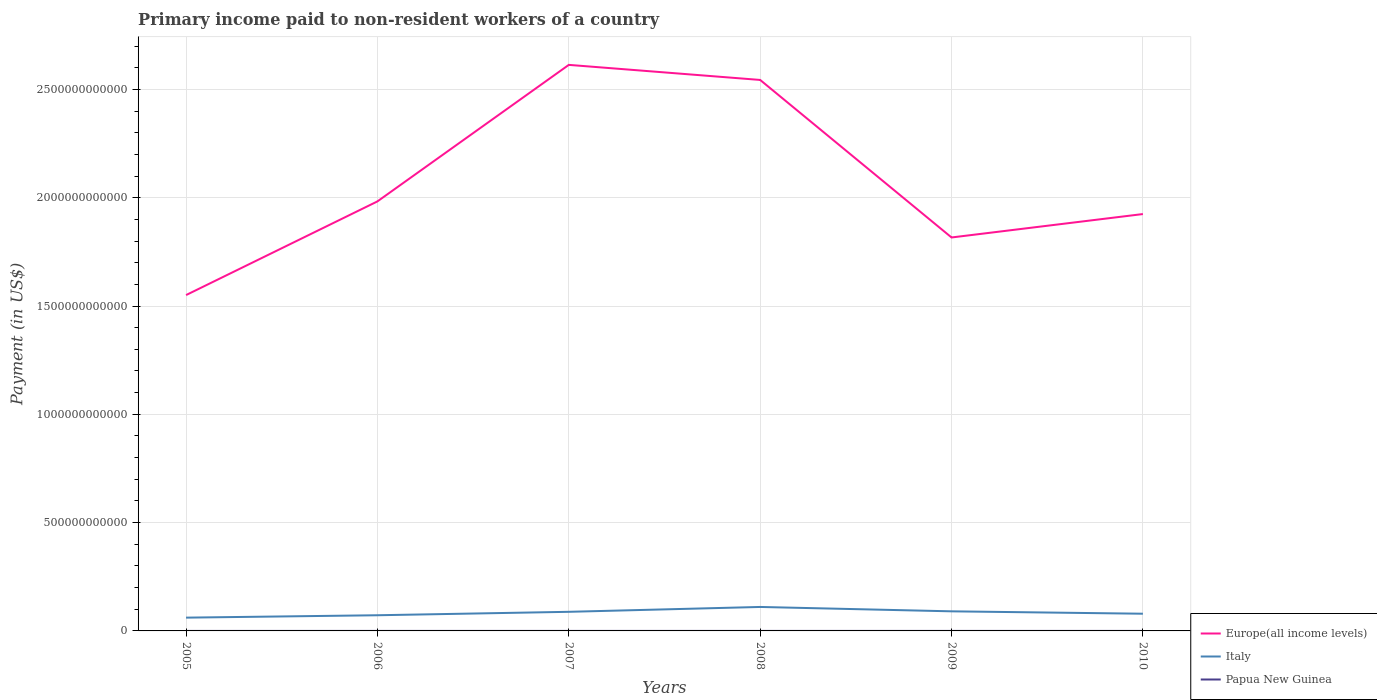How many different coloured lines are there?
Provide a succinct answer. 3. Across all years, what is the maximum amount paid to workers in Italy?
Keep it short and to the point. 6.13e+1. In which year was the amount paid to workers in Europe(all income levels) maximum?
Your response must be concise. 2005. What is the total amount paid to workers in Papua New Guinea in the graph?
Your answer should be compact. -7.82e+07. What is the difference between the highest and the second highest amount paid to workers in Papua New Guinea?
Your answer should be compact. 7.82e+07. What is the difference between two consecutive major ticks on the Y-axis?
Keep it short and to the point. 5.00e+11. Does the graph contain any zero values?
Provide a short and direct response. No. Does the graph contain grids?
Keep it short and to the point. Yes. Where does the legend appear in the graph?
Your answer should be very brief. Bottom right. How many legend labels are there?
Ensure brevity in your answer.  3. How are the legend labels stacked?
Keep it short and to the point. Vertical. What is the title of the graph?
Ensure brevity in your answer.  Primary income paid to non-resident workers of a country. Does "Cabo Verde" appear as one of the legend labels in the graph?
Offer a terse response. No. What is the label or title of the Y-axis?
Your answer should be compact. Payment (in US$). What is the Payment (in US$) in Europe(all income levels) in 2005?
Make the answer very short. 1.55e+12. What is the Payment (in US$) in Italy in 2005?
Your answer should be very brief. 6.13e+1. What is the Payment (in US$) of Papua New Guinea in 2005?
Your response must be concise. 2.61e+07. What is the Payment (in US$) of Europe(all income levels) in 2006?
Make the answer very short. 1.98e+12. What is the Payment (in US$) in Italy in 2006?
Make the answer very short. 7.24e+1. What is the Payment (in US$) in Papua New Guinea in 2006?
Offer a terse response. 7.03e+07. What is the Payment (in US$) of Europe(all income levels) in 2007?
Your answer should be very brief. 2.61e+12. What is the Payment (in US$) in Italy in 2007?
Provide a succinct answer. 8.82e+1. What is the Payment (in US$) in Papua New Guinea in 2007?
Your answer should be compact. 1.04e+08. What is the Payment (in US$) in Europe(all income levels) in 2008?
Provide a short and direct response. 2.54e+12. What is the Payment (in US$) in Italy in 2008?
Offer a very short reply. 1.11e+11. What is the Payment (in US$) in Papua New Guinea in 2008?
Make the answer very short. 8.51e+07. What is the Payment (in US$) in Europe(all income levels) in 2009?
Offer a very short reply. 1.82e+12. What is the Payment (in US$) of Italy in 2009?
Your answer should be very brief. 9.04e+1. What is the Payment (in US$) of Papua New Guinea in 2009?
Offer a terse response. 4.63e+07. What is the Payment (in US$) of Europe(all income levels) in 2010?
Offer a very short reply. 1.92e+12. What is the Payment (in US$) of Italy in 2010?
Offer a very short reply. 7.94e+1. What is the Payment (in US$) in Papua New Guinea in 2010?
Ensure brevity in your answer.  4.16e+07. Across all years, what is the maximum Payment (in US$) of Europe(all income levels)?
Provide a succinct answer. 2.61e+12. Across all years, what is the maximum Payment (in US$) in Italy?
Your response must be concise. 1.11e+11. Across all years, what is the maximum Payment (in US$) in Papua New Guinea?
Your answer should be compact. 1.04e+08. Across all years, what is the minimum Payment (in US$) of Europe(all income levels)?
Offer a very short reply. 1.55e+12. Across all years, what is the minimum Payment (in US$) in Italy?
Offer a very short reply. 6.13e+1. Across all years, what is the minimum Payment (in US$) of Papua New Guinea?
Offer a terse response. 2.61e+07. What is the total Payment (in US$) of Europe(all income levels) in the graph?
Your answer should be very brief. 1.24e+13. What is the total Payment (in US$) in Italy in the graph?
Ensure brevity in your answer.  5.02e+11. What is the total Payment (in US$) in Papua New Guinea in the graph?
Offer a very short reply. 3.74e+08. What is the difference between the Payment (in US$) of Europe(all income levels) in 2005 and that in 2006?
Provide a short and direct response. -4.33e+11. What is the difference between the Payment (in US$) of Italy in 2005 and that in 2006?
Provide a succinct answer. -1.10e+1. What is the difference between the Payment (in US$) of Papua New Guinea in 2005 and that in 2006?
Give a very brief answer. -4.42e+07. What is the difference between the Payment (in US$) in Europe(all income levels) in 2005 and that in 2007?
Offer a terse response. -1.06e+12. What is the difference between the Payment (in US$) in Italy in 2005 and that in 2007?
Make the answer very short. -2.69e+1. What is the difference between the Payment (in US$) in Papua New Guinea in 2005 and that in 2007?
Offer a very short reply. -7.82e+07. What is the difference between the Payment (in US$) of Europe(all income levels) in 2005 and that in 2008?
Offer a terse response. -9.93e+11. What is the difference between the Payment (in US$) in Italy in 2005 and that in 2008?
Give a very brief answer. -4.93e+1. What is the difference between the Payment (in US$) of Papua New Guinea in 2005 and that in 2008?
Ensure brevity in your answer.  -5.90e+07. What is the difference between the Payment (in US$) in Europe(all income levels) in 2005 and that in 2009?
Provide a succinct answer. -2.66e+11. What is the difference between the Payment (in US$) of Italy in 2005 and that in 2009?
Ensure brevity in your answer.  -2.91e+1. What is the difference between the Payment (in US$) in Papua New Guinea in 2005 and that in 2009?
Keep it short and to the point. -2.02e+07. What is the difference between the Payment (in US$) of Europe(all income levels) in 2005 and that in 2010?
Provide a short and direct response. -3.74e+11. What is the difference between the Payment (in US$) of Italy in 2005 and that in 2010?
Your answer should be compact. -1.81e+1. What is the difference between the Payment (in US$) of Papua New Guinea in 2005 and that in 2010?
Provide a succinct answer. -1.54e+07. What is the difference between the Payment (in US$) of Europe(all income levels) in 2006 and that in 2007?
Provide a short and direct response. -6.30e+11. What is the difference between the Payment (in US$) in Italy in 2006 and that in 2007?
Make the answer very short. -1.59e+1. What is the difference between the Payment (in US$) in Papua New Guinea in 2006 and that in 2007?
Make the answer very short. -3.40e+07. What is the difference between the Payment (in US$) in Europe(all income levels) in 2006 and that in 2008?
Offer a terse response. -5.61e+11. What is the difference between the Payment (in US$) of Italy in 2006 and that in 2008?
Your answer should be very brief. -3.83e+1. What is the difference between the Payment (in US$) of Papua New Guinea in 2006 and that in 2008?
Offer a terse response. -1.48e+07. What is the difference between the Payment (in US$) in Europe(all income levels) in 2006 and that in 2009?
Your answer should be compact. 1.67e+11. What is the difference between the Payment (in US$) in Italy in 2006 and that in 2009?
Provide a short and direct response. -1.81e+1. What is the difference between the Payment (in US$) of Papua New Guinea in 2006 and that in 2009?
Your answer should be very brief. 2.40e+07. What is the difference between the Payment (in US$) of Europe(all income levels) in 2006 and that in 2010?
Your response must be concise. 5.85e+1. What is the difference between the Payment (in US$) in Italy in 2006 and that in 2010?
Provide a short and direct response. -7.08e+09. What is the difference between the Payment (in US$) of Papua New Guinea in 2006 and that in 2010?
Provide a short and direct response. 2.87e+07. What is the difference between the Payment (in US$) in Europe(all income levels) in 2007 and that in 2008?
Ensure brevity in your answer.  6.96e+1. What is the difference between the Payment (in US$) in Italy in 2007 and that in 2008?
Your answer should be compact. -2.24e+1. What is the difference between the Payment (in US$) in Papua New Guinea in 2007 and that in 2008?
Provide a succinct answer. 1.92e+07. What is the difference between the Payment (in US$) of Europe(all income levels) in 2007 and that in 2009?
Ensure brevity in your answer.  7.97e+11. What is the difference between the Payment (in US$) in Italy in 2007 and that in 2009?
Your response must be concise. -2.21e+09. What is the difference between the Payment (in US$) of Papua New Guinea in 2007 and that in 2009?
Your answer should be very brief. 5.80e+07. What is the difference between the Payment (in US$) of Europe(all income levels) in 2007 and that in 2010?
Offer a terse response. 6.89e+11. What is the difference between the Payment (in US$) of Italy in 2007 and that in 2010?
Offer a very short reply. 8.79e+09. What is the difference between the Payment (in US$) in Papua New Guinea in 2007 and that in 2010?
Offer a very short reply. 6.28e+07. What is the difference between the Payment (in US$) in Europe(all income levels) in 2008 and that in 2009?
Ensure brevity in your answer.  7.27e+11. What is the difference between the Payment (in US$) in Italy in 2008 and that in 2009?
Your answer should be very brief. 2.02e+1. What is the difference between the Payment (in US$) in Papua New Guinea in 2008 and that in 2009?
Provide a short and direct response. 3.88e+07. What is the difference between the Payment (in US$) in Europe(all income levels) in 2008 and that in 2010?
Provide a short and direct response. 6.19e+11. What is the difference between the Payment (in US$) in Italy in 2008 and that in 2010?
Your answer should be compact. 3.12e+1. What is the difference between the Payment (in US$) of Papua New Guinea in 2008 and that in 2010?
Ensure brevity in your answer.  4.36e+07. What is the difference between the Payment (in US$) in Europe(all income levels) in 2009 and that in 2010?
Make the answer very short. -1.08e+11. What is the difference between the Payment (in US$) in Italy in 2009 and that in 2010?
Offer a very short reply. 1.10e+1. What is the difference between the Payment (in US$) in Papua New Guinea in 2009 and that in 2010?
Offer a terse response. 4.76e+06. What is the difference between the Payment (in US$) of Europe(all income levels) in 2005 and the Payment (in US$) of Italy in 2006?
Keep it short and to the point. 1.48e+12. What is the difference between the Payment (in US$) in Europe(all income levels) in 2005 and the Payment (in US$) in Papua New Guinea in 2006?
Offer a very short reply. 1.55e+12. What is the difference between the Payment (in US$) of Italy in 2005 and the Payment (in US$) of Papua New Guinea in 2006?
Ensure brevity in your answer.  6.13e+1. What is the difference between the Payment (in US$) of Europe(all income levels) in 2005 and the Payment (in US$) of Italy in 2007?
Give a very brief answer. 1.46e+12. What is the difference between the Payment (in US$) in Europe(all income levels) in 2005 and the Payment (in US$) in Papua New Guinea in 2007?
Keep it short and to the point. 1.55e+12. What is the difference between the Payment (in US$) in Italy in 2005 and the Payment (in US$) in Papua New Guinea in 2007?
Keep it short and to the point. 6.12e+1. What is the difference between the Payment (in US$) in Europe(all income levels) in 2005 and the Payment (in US$) in Italy in 2008?
Ensure brevity in your answer.  1.44e+12. What is the difference between the Payment (in US$) of Europe(all income levels) in 2005 and the Payment (in US$) of Papua New Guinea in 2008?
Provide a succinct answer. 1.55e+12. What is the difference between the Payment (in US$) in Italy in 2005 and the Payment (in US$) in Papua New Guinea in 2008?
Ensure brevity in your answer.  6.12e+1. What is the difference between the Payment (in US$) in Europe(all income levels) in 2005 and the Payment (in US$) in Italy in 2009?
Give a very brief answer. 1.46e+12. What is the difference between the Payment (in US$) in Europe(all income levels) in 2005 and the Payment (in US$) in Papua New Guinea in 2009?
Provide a short and direct response. 1.55e+12. What is the difference between the Payment (in US$) in Italy in 2005 and the Payment (in US$) in Papua New Guinea in 2009?
Ensure brevity in your answer.  6.13e+1. What is the difference between the Payment (in US$) in Europe(all income levels) in 2005 and the Payment (in US$) in Italy in 2010?
Your answer should be very brief. 1.47e+12. What is the difference between the Payment (in US$) of Europe(all income levels) in 2005 and the Payment (in US$) of Papua New Guinea in 2010?
Your answer should be very brief. 1.55e+12. What is the difference between the Payment (in US$) in Italy in 2005 and the Payment (in US$) in Papua New Guinea in 2010?
Ensure brevity in your answer.  6.13e+1. What is the difference between the Payment (in US$) of Europe(all income levels) in 2006 and the Payment (in US$) of Italy in 2007?
Your response must be concise. 1.89e+12. What is the difference between the Payment (in US$) in Europe(all income levels) in 2006 and the Payment (in US$) in Papua New Guinea in 2007?
Make the answer very short. 1.98e+12. What is the difference between the Payment (in US$) in Italy in 2006 and the Payment (in US$) in Papua New Guinea in 2007?
Your answer should be compact. 7.22e+1. What is the difference between the Payment (in US$) of Europe(all income levels) in 2006 and the Payment (in US$) of Italy in 2008?
Your answer should be compact. 1.87e+12. What is the difference between the Payment (in US$) of Europe(all income levels) in 2006 and the Payment (in US$) of Papua New Guinea in 2008?
Your response must be concise. 1.98e+12. What is the difference between the Payment (in US$) of Italy in 2006 and the Payment (in US$) of Papua New Guinea in 2008?
Your response must be concise. 7.23e+1. What is the difference between the Payment (in US$) of Europe(all income levels) in 2006 and the Payment (in US$) of Italy in 2009?
Give a very brief answer. 1.89e+12. What is the difference between the Payment (in US$) of Europe(all income levels) in 2006 and the Payment (in US$) of Papua New Guinea in 2009?
Offer a very short reply. 1.98e+12. What is the difference between the Payment (in US$) in Italy in 2006 and the Payment (in US$) in Papua New Guinea in 2009?
Provide a short and direct response. 7.23e+1. What is the difference between the Payment (in US$) in Europe(all income levels) in 2006 and the Payment (in US$) in Italy in 2010?
Give a very brief answer. 1.90e+12. What is the difference between the Payment (in US$) in Europe(all income levels) in 2006 and the Payment (in US$) in Papua New Guinea in 2010?
Keep it short and to the point. 1.98e+12. What is the difference between the Payment (in US$) in Italy in 2006 and the Payment (in US$) in Papua New Guinea in 2010?
Offer a very short reply. 7.23e+1. What is the difference between the Payment (in US$) in Europe(all income levels) in 2007 and the Payment (in US$) in Italy in 2008?
Give a very brief answer. 2.50e+12. What is the difference between the Payment (in US$) of Europe(all income levels) in 2007 and the Payment (in US$) of Papua New Guinea in 2008?
Keep it short and to the point. 2.61e+12. What is the difference between the Payment (in US$) in Italy in 2007 and the Payment (in US$) in Papua New Guinea in 2008?
Offer a very short reply. 8.81e+1. What is the difference between the Payment (in US$) in Europe(all income levels) in 2007 and the Payment (in US$) in Italy in 2009?
Your answer should be very brief. 2.52e+12. What is the difference between the Payment (in US$) of Europe(all income levels) in 2007 and the Payment (in US$) of Papua New Guinea in 2009?
Offer a terse response. 2.61e+12. What is the difference between the Payment (in US$) of Italy in 2007 and the Payment (in US$) of Papua New Guinea in 2009?
Offer a terse response. 8.82e+1. What is the difference between the Payment (in US$) of Europe(all income levels) in 2007 and the Payment (in US$) of Italy in 2010?
Provide a short and direct response. 2.53e+12. What is the difference between the Payment (in US$) in Europe(all income levels) in 2007 and the Payment (in US$) in Papua New Guinea in 2010?
Make the answer very short. 2.61e+12. What is the difference between the Payment (in US$) in Italy in 2007 and the Payment (in US$) in Papua New Guinea in 2010?
Give a very brief answer. 8.82e+1. What is the difference between the Payment (in US$) in Europe(all income levels) in 2008 and the Payment (in US$) in Italy in 2009?
Give a very brief answer. 2.45e+12. What is the difference between the Payment (in US$) of Europe(all income levels) in 2008 and the Payment (in US$) of Papua New Guinea in 2009?
Ensure brevity in your answer.  2.54e+12. What is the difference between the Payment (in US$) in Italy in 2008 and the Payment (in US$) in Papua New Guinea in 2009?
Provide a succinct answer. 1.11e+11. What is the difference between the Payment (in US$) in Europe(all income levels) in 2008 and the Payment (in US$) in Italy in 2010?
Ensure brevity in your answer.  2.46e+12. What is the difference between the Payment (in US$) of Europe(all income levels) in 2008 and the Payment (in US$) of Papua New Guinea in 2010?
Provide a short and direct response. 2.54e+12. What is the difference between the Payment (in US$) of Italy in 2008 and the Payment (in US$) of Papua New Guinea in 2010?
Offer a terse response. 1.11e+11. What is the difference between the Payment (in US$) of Europe(all income levels) in 2009 and the Payment (in US$) of Italy in 2010?
Ensure brevity in your answer.  1.74e+12. What is the difference between the Payment (in US$) of Europe(all income levels) in 2009 and the Payment (in US$) of Papua New Guinea in 2010?
Offer a terse response. 1.82e+12. What is the difference between the Payment (in US$) in Italy in 2009 and the Payment (in US$) in Papua New Guinea in 2010?
Make the answer very short. 9.04e+1. What is the average Payment (in US$) of Europe(all income levels) per year?
Offer a very short reply. 2.07e+12. What is the average Payment (in US$) in Italy per year?
Ensure brevity in your answer.  8.37e+1. What is the average Payment (in US$) in Papua New Guinea per year?
Give a very brief answer. 6.23e+07. In the year 2005, what is the difference between the Payment (in US$) of Europe(all income levels) and Payment (in US$) of Italy?
Make the answer very short. 1.49e+12. In the year 2005, what is the difference between the Payment (in US$) of Europe(all income levels) and Payment (in US$) of Papua New Guinea?
Your answer should be compact. 1.55e+12. In the year 2005, what is the difference between the Payment (in US$) of Italy and Payment (in US$) of Papua New Guinea?
Keep it short and to the point. 6.13e+1. In the year 2006, what is the difference between the Payment (in US$) in Europe(all income levels) and Payment (in US$) in Italy?
Ensure brevity in your answer.  1.91e+12. In the year 2006, what is the difference between the Payment (in US$) of Europe(all income levels) and Payment (in US$) of Papua New Guinea?
Give a very brief answer. 1.98e+12. In the year 2006, what is the difference between the Payment (in US$) in Italy and Payment (in US$) in Papua New Guinea?
Your answer should be compact. 7.23e+1. In the year 2007, what is the difference between the Payment (in US$) in Europe(all income levels) and Payment (in US$) in Italy?
Your answer should be compact. 2.53e+12. In the year 2007, what is the difference between the Payment (in US$) in Europe(all income levels) and Payment (in US$) in Papua New Guinea?
Your answer should be compact. 2.61e+12. In the year 2007, what is the difference between the Payment (in US$) in Italy and Payment (in US$) in Papua New Guinea?
Keep it short and to the point. 8.81e+1. In the year 2008, what is the difference between the Payment (in US$) in Europe(all income levels) and Payment (in US$) in Italy?
Your answer should be compact. 2.43e+12. In the year 2008, what is the difference between the Payment (in US$) of Europe(all income levels) and Payment (in US$) of Papua New Guinea?
Your response must be concise. 2.54e+12. In the year 2008, what is the difference between the Payment (in US$) in Italy and Payment (in US$) in Papua New Guinea?
Make the answer very short. 1.11e+11. In the year 2009, what is the difference between the Payment (in US$) in Europe(all income levels) and Payment (in US$) in Italy?
Provide a short and direct response. 1.73e+12. In the year 2009, what is the difference between the Payment (in US$) in Europe(all income levels) and Payment (in US$) in Papua New Guinea?
Offer a very short reply. 1.82e+12. In the year 2009, what is the difference between the Payment (in US$) in Italy and Payment (in US$) in Papua New Guinea?
Offer a terse response. 9.04e+1. In the year 2010, what is the difference between the Payment (in US$) in Europe(all income levels) and Payment (in US$) in Italy?
Offer a terse response. 1.85e+12. In the year 2010, what is the difference between the Payment (in US$) of Europe(all income levels) and Payment (in US$) of Papua New Guinea?
Ensure brevity in your answer.  1.92e+12. In the year 2010, what is the difference between the Payment (in US$) in Italy and Payment (in US$) in Papua New Guinea?
Your answer should be compact. 7.94e+1. What is the ratio of the Payment (in US$) in Europe(all income levels) in 2005 to that in 2006?
Keep it short and to the point. 0.78. What is the ratio of the Payment (in US$) of Italy in 2005 to that in 2006?
Give a very brief answer. 0.85. What is the ratio of the Payment (in US$) of Papua New Guinea in 2005 to that in 2006?
Keep it short and to the point. 0.37. What is the ratio of the Payment (in US$) of Europe(all income levels) in 2005 to that in 2007?
Keep it short and to the point. 0.59. What is the ratio of the Payment (in US$) in Italy in 2005 to that in 2007?
Ensure brevity in your answer.  0.7. What is the ratio of the Payment (in US$) in Papua New Guinea in 2005 to that in 2007?
Give a very brief answer. 0.25. What is the ratio of the Payment (in US$) in Europe(all income levels) in 2005 to that in 2008?
Offer a terse response. 0.61. What is the ratio of the Payment (in US$) of Italy in 2005 to that in 2008?
Provide a short and direct response. 0.55. What is the ratio of the Payment (in US$) of Papua New Guinea in 2005 to that in 2008?
Provide a short and direct response. 0.31. What is the ratio of the Payment (in US$) in Europe(all income levels) in 2005 to that in 2009?
Ensure brevity in your answer.  0.85. What is the ratio of the Payment (in US$) in Italy in 2005 to that in 2009?
Give a very brief answer. 0.68. What is the ratio of the Payment (in US$) of Papua New Guinea in 2005 to that in 2009?
Offer a very short reply. 0.56. What is the ratio of the Payment (in US$) in Europe(all income levels) in 2005 to that in 2010?
Your response must be concise. 0.81. What is the ratio of the Payment (in US$) in Italy in 2005 to that in 2010?
Keep it short and to the point. 0.77. What is the ratio of the Payment (in US$) of Papua New Guinea in 2005 to that in 2010?
Your response must be concise. 0.63. What is the ratio of the Payment (in US$) in Europe(all income levels) in 2006 to that in 2007?
Your answer should be compact. 0.76. What is the ratio of the Payment (in US$) in Italy in 2006 to that in 2007?
Give a very brief answer. 0.82. What is the ratio of the Payment (in US$) of Papua New Guinea in 2006 to that in 2007?
Offer a terse response. 0.67. What is the ratio of the Payment (in US$) in Europe(all income levels) in 2006 to that in 2008?
Your response must be concise. 0.78. What is the ratio of the Payment (in US$) of Italy in 2006 to that in 2008?
Make the answer very short. 0.65. What is the ratio of the Payment (in US$) of Papua New Guinea in 2006 to that in 2008?
Provide a succinct answer. 0.83. What is the ratio of the Payment (in US$) of Europe(all income levels) in 2006 to that in 2009?
Provide a succinct answer. 1.09. What is the ratio of the Payment (in US$) in Italy in 2006 to that in 2009?
Provide a short and direct response. 0.8. What is the ratio of the Payment (in US$) in Papua New Guinea in 2006 to that in 2009?
Your answer should be very brief. 1.52. What is the ratio of the Payment (in US$) in Europe(all income levels) in 2006 to that in 2010?
Provide a succinct answer. 1.03. What is the ratio of the Payment (in US$) of Italy in 2006 to that in 2010?
Your answer should be compact. 0.91. What is the ratio of the Payment (in US$) in Papua New Guinea in 2006 to that in 2010?
Your answer should be compact. 1.69. What is the ratio of the Payment (in US$) of Europe(all income levels) in 2007 to that in 2008?
Offer a terse response. 1.03. What is the ratio of the Payment (in US$) in Italy in 2007 to that in 2008?
Your answer should be compact. 0.8. What is the ratio of the Payment (in US$) in Papua New Guinea in 2007 to that in 2008?
Give a very brief answer. 1.23. What is the ratio of the Payment (in US$) of Europe(all income levels) in 2007 to that in 2009?
Provide a succinct answer. 1.44. What is the ratio of the Payment (in US$) in Italy in 2007 to that in 2009?
Provide a short and direct response. 0.98. What is the ratio of the Payment (in US$) of Papua New Guinea in 2007 to that in 2009?
Offer a very short reply. 2.25. What is the ratio of the Payment (in US$) in Europe(all income levels) in 2007 to that in 2010?
Provide a short and direct response. 1.36. What is the ratio of the Payment (in US$) of Italy in 2007 to that in 2010?
Your answer should be very brief. 1.11. What is the ratio of the Payment (in US$) in Papua New Guinea in 2007 to that in 2010?
Your answer should be compact. 2.51. What is the ratio of the Payment (in US$) in Europe(all income levels) in 2008 to that in 2009?
Make the answer very short. 1.4. What is the ratio of the Payment (in US$) of Italy in 2008 to that in 2009?
Provide a short and direct response. 1.22. What is the ratio of the Payment (in US$) of Papua New Guinea in 2008 to that in 2009?
Offer a terse response. 1.84. What is the ratio of the Payment (in US$) in Europe(all income levels) in 2008 to that in 2010?
Ensure brevity in your answer.  1.32. What is the ratio of the Payment (in US$) of Italy in 2008 to that in 2010?
Your response must be concise. 1.39. What is the ratio of the Payment (in US$) of Papua New Guinea in 2008 to that in 2010?
Give a very brief answer. 2.05. What is the ratio of the Payment (in US$) of Europe(all income levels) in 2009 to that in 2010?
Your answer should be compact. 0.94. What is the ratio of the Payment (in US$) of Italy in 2009 to that in 2010?
Your response must be concise. 1.14. What is the ratio of the Payment (in US$) of Papua New Guinea in 2009 to that in 2010?
Make the answer very short. 1.11. What is the difference between the highest and the second highest Payment (in US$) of Europe(all income levels)?
Provide a succinct answer. 6.96e+1. What is the difference between the highest and the second highest Payment (in US$) in Italy?
Your answer should be compact. 2.02e+1. What is the difference between the highest and the second highest Payment (in US$) of Papua New Guinea?
Keep it short and to the point. 1.92e+07. What is the difference between the highest and the lowest Payment (in US$) of Europe(all income levels)?
Offer a very short reply. 1.06e+12. What is the difference between the highest and the lowest Payment (in US$) of Italy?
Provide a succinct answer. 4.93e+1. What is the difference between the highest and the lowest Payment (in US$) in Papua New Guinea?
Provide a succinct answer. 7.82e+07. 